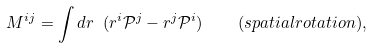Convert formula to latex. <formula><loc_0><loc_0><loc_500><loc_500>M ^ { i j } = \int d r \ ( r ^ { i } \mathcal { P } ^ { j } - r ^ { j } \mathcal { P } ^ { i } ) \quad ( s p a t i a l r o t a t i o n ) ,</formula> 